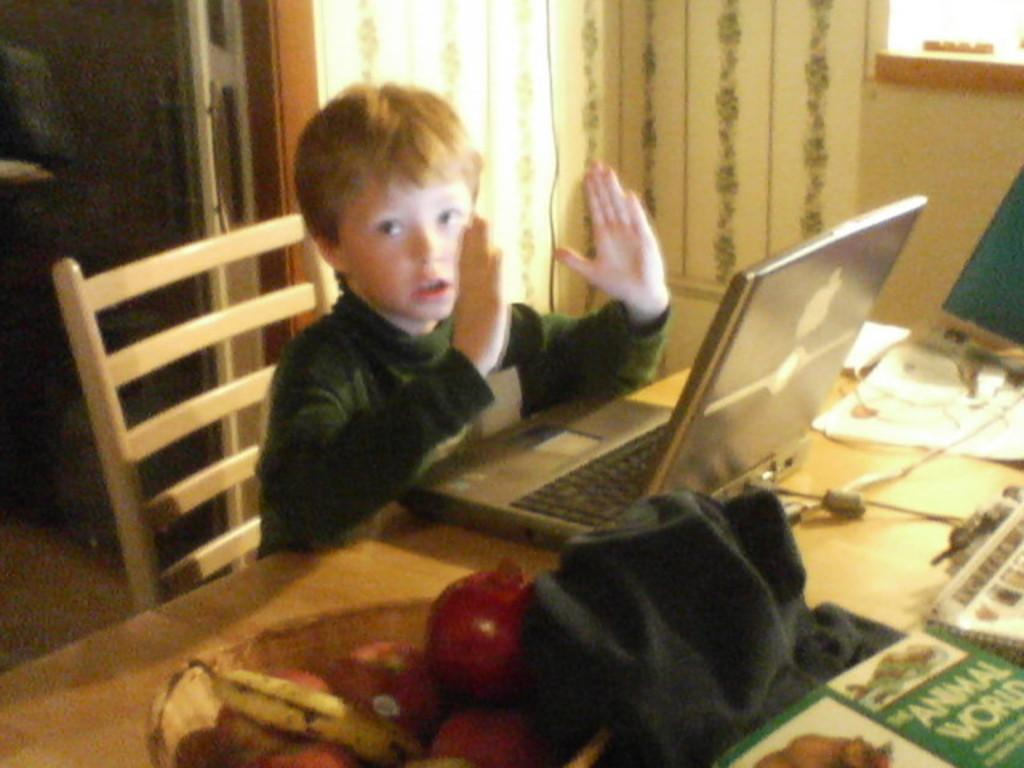What is the main subject of the image? The main subject of the image is a kid. What is the kid doing in the image? The kid is sitting on a chair. Where is the chair located in relation to the table? The chair is in front of a table. What can be seen on the table in the image? There are laptops and a basket with fruits on the table. How many cables are connected to the laptops in the image? There is no information about cables in the image; only the presence of laptops and a basket of fruits is mentioned. 